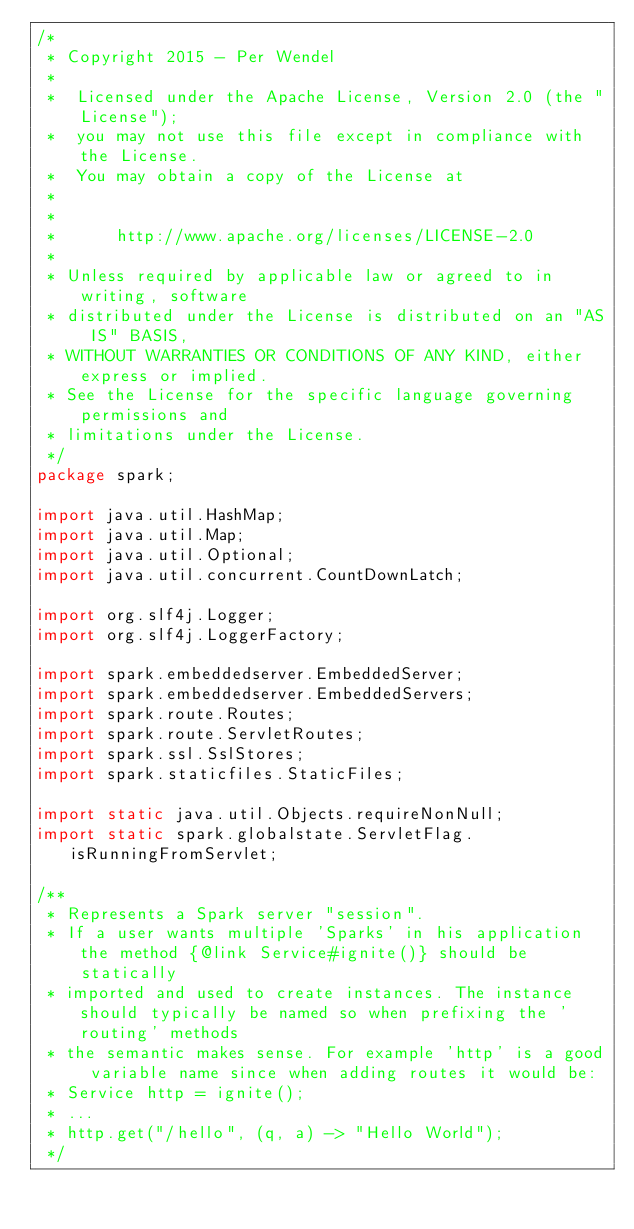Convert code to text. <code><loc_0><loc_0><loc_500><loc_500><_Java_>/*
 * Copyright 2015 - Per Wendel
 *
 *  Licensed under the Apache License, Version 2.0 (the "License");
 *  you may not use this file except in compliance with the License.
 *  You may obtain a copy of the License at
 *
 *
 *      http://www.apache.org/licenses/LICENSE-2.0
 *
 * Unless required by applicable law or agreed to in writing, software
 * distributed under the License is distributed on an "AS IS" BASIS,
 * WITHOUT WARRANTIES OR CONDITIONS OF ANY KIND, either express or implied.
 * See the License for the specific language governing permissions and
 * limitations under the License.
 */
package spark;

import java.util.HashMap;
import java.util.Map;
import java.util.Optional;
import java.util.concurrent.CountDownLatch;

import org.slf4j.Logger;
import org.slf4j.LoggerFactory;

import spark.embeddedserver.EmbeddedServer;
import spark.embeddedserver.EmbeddedServers;
import spark.route.Routes;
import spark.route.ServletRoutes;
import spark.ssl.SslStores;
import spark.staticfiles.StaticFiles;

import static java.util.Objects.requireNonNull;
import static spark.globalstate.ServletFlag.isRunningFromServlet;

/**
 * Represents a Spark server "session".
 * If a user wants multiple 'Sparks' in his application the method {@link Service#ignite()} should be statically
 * imported and used to create instances. The instance should typically be named so when prefixing the 'routing' methods
 * the semantic makes sense. For example 'http' is a good variable name since when adding routes it would be:
 * Service http = ignite();
 * ...
 * http.get("/hello", (q, a) -> "Hello World");
 */</code> 